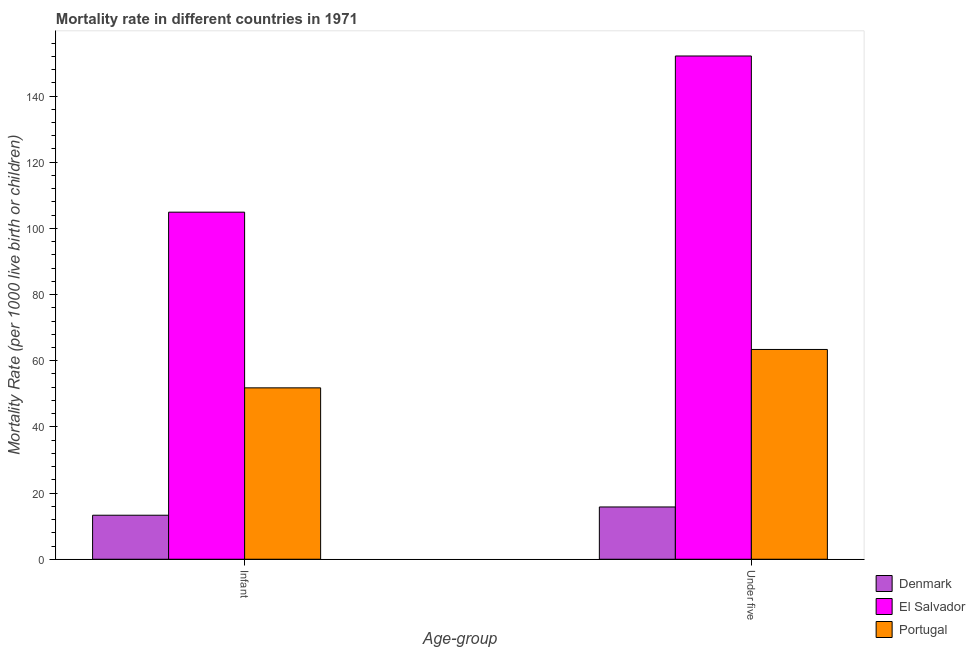How many groups of bars are there?
Your response must be concise. 2. Are the number of bars per tick equal to the number of legend labels?
Provide a short and direct response. Yes. Are the number of bars on each tick of the X-axis equal?
Offer a terse response. Yes. How many bars are there on the 2nd tick from the left?
Your answer should be very brief. 3. What is the label of the 2nd group of bars from the left?
Keep it short and to the point. Under five. What is the infant mortality rate in Portugal?
Ensure brevity in your answer.  51.8. Across all countries, what is the maximum infant mortality rate?
Provide a short and direct response. 104.9. In which country was the under-5 mortality rate maximum?
Offer a very short reply. El Salvador. What is the total infant mortality rate in the graph?
Provide a short and direct response. 170. What is the difference between the under-5 mortality rate in El Salvador and that in Portugal?
Your answer should be compact. 88.7. What is the difference between the infant mortality rate in Denmark and the under-5 mortality rate in Portugal?
Ensure brevity in your answer.  -50.1. What is the average infant mortality rate per country?
Your response must be concise. 56.67. What is the difference between the under-5 mortality rate and infant mortality rate in Portugal?
Make the answer very short. 11.6. What is the ratio of the under-5 mortality rate in Denmark to that in Portugal?
Give a very brief answer. 0.25. In how many countries, is the infant mortality rate greater than the average infant mortality rate taken over all countries?
Provide a succinct answer. 1. What does the 2nd bar from the left in Under five represents?
Provide a succinct answer. El Salvador. How many bars are there?
Your response must be concise. 6. Are all the bars in the graph horizontal?
Ensure brevity in your answer.  No. How many countries are there in the graph?
Make the answer very short. 3. What is the difference between two consecutive major ticks on the Y-axis?
Your answer should be compact. 20. Are the values on the major ticks of Y-axis written in scientific E-notation?
Offer a terse response. No. Does the graph contain any zero values?
Provide a short and direct response. No. Does the graph contain grids?
Keep it short and to the point. No. Where does the legend appear in the graph?
Provide a short and direct response. Bottom right. How are the legend labels stacked?
Your answer should be compact. Vertical. What is the title of the graph?
Your answer should be compact. Mortality rate in different countries in 1971. Does "Croatia" appear as one of the legend labels in the graph?
Provide a short and direct response. No. What is the label or title of the X-axis?
Your response must be concise. Age-group. What is the label or title of the Y-axis?
Make the answer very short. Mortality Rate (per 1000 live birth or children). What is the Mortality Rate (per 1000 live birth or children) in Denmark in Infant?
Your answer should be very brief. 13.3. What is the Mortality Rate (per 1000 live birth or children) in El Salvador in Infant?
Provide a short and direct response. 104.9. What is the Mortality Rate (per 1000 live birth or children) of Portugal in Infant?
Make the answer very short. 51.8. What is the Mortality Rate (per 1000 live birth or children) in Denmark in Under five?
Offer a very short reply. 15.8. What is the Mortality Rate (per 1000 live birth or children) in El Salvador in Under five?
Offer a terse response. 152.1. What is the Mortality Rate (per 1000 live birth or children) of Portugal in Under five?
Offer a very short reply. 63.4. Across all Age-group, what is the maximum Mortality Rate (per 1000 live birth or children) of Denmark?
Provide a short and direct response. 15.8. Across all Age-group, what is the maximum Mortality Rate (per 1000 live birth or children) of El Salvador?
Ensure brevity in your answer.  152.1. Across all Age-group, what is the maximum Mortality Rate (per 1000 live birth or children) of Portugal?
Your answer should be very brief. 63.4. Across all Age-group, what is the minimum Mortality Rate (per 1000 live birth or children) of El Salvador?
Your answer should be compact. 104.9. Across all Age-group, what is the minimum Mortality Rate (per 1000 live birth or children) of Portugal?
Your answer should be compact. 51.8. What is the total Mortality Rate (per 1000 live birth or children) in Denmark in the graph?
Ensure brevity in your answer.  29.1. What is the total Mortality Rate (per 1000 live birth or children) in El Salvador in the graph?
Provide a succinct answer. 257. What is the total Mortality Rate (per 1000 live birth or children) in Portugal in the graph?
Keep it short and to the point. 115.2. What is the difference between the Mortality Rate (per 1000 live birth or children) of Denmark in Infant and that in Under five?
Offer a terse response. -2.5. What is the difference between the Mortality Rate (per 1000 live birth or children) in El Salvador in Infant and that in Under five?
Give a very brief answer. -47.2. What is the difference between the Mortality Rate (per 1000 live birth or children) of Portugal in Infant and that in Under five?
Offer a very short reply. -11.6. What is the difference between the Mortality Rate (per 1000 live birth or children) of Denmark in Infant and the Mortality Rate (per 1000 live birth or children) of El Salvador in Under five?
Keep it short and to the point. -138.8. What is the difference between the Mortality Rate (per 1000 live birth or children) of Denmark in Infant and the Mortality Rate (per 1000 live birth or children) of Portugal in Under five?
Provide a succinct answer. -50.1. What is the difference between the Mortality Rate (per 1000 live birth or children) of El Salvador in Infant and the Mortality Rate (per 1000 live birth or children) of Portugal in Under five?
Give a very brief answer. 41.5. What is the average Mortality Rate (per 1000 live birth or children) in Denmark per Age-group?
Ensure brevity in your answer.  14.55. What is the average Mortality Rate (per 1000 live birth or children) in El Salvador per Age-group?
Give a very brief answer. 128.5. What is the average Mortality Rate (per 1000 live birth or children) in Portugal per Age-group?
Make the answer very short. 57.6. What is the difference between the Mortality Rate (per 1000 live birth or children) of Denmark and Mortality Rate (per 1000 live birth or children) of El Salvador in Infant?
Offer a very short reply. -91.6. What is the difference between the Mortality Rate (per 1000 live birth or children) in Denmark and Mortality Rate (per 1000 live birth or children) in Portugal in Infant?
Offer a terse response. -38.5. What is the difference between the Mortality Rate (per 1000 live birth or children) of El Salvador and Mortality Rate (per 1000 live birth or children) of Portugal in Infant?
Offer a very short reply. 53.1. What is the difference between the Mortality Rate (per 1000 live birth or children) in Denmark and Mortality Rate (per 1000 live birth or children) in El Salvador in Under five?
Ensure brevity in your answer.  -136.3. What is the difference between the Mortality Rate (per 1000 live birth or children) in Denmark and Mortality Rate (per 1000 live birth or children) in Portugal in Under five?
Your answer should be very brief. -47.6. What is the difference between the Mortality Rate (per 1000 live birth or children) in El Salvador and Mortality Rate (per 1000 live birth or children) in Portugal in Under five?
Your response must be concise. 88.7. What is the ratio of the Mortality Rate (per 1000 live birth or children) of Denmark in Infant to that in Under five?
Provide a succinct answer. 0.84. What is the ratio of the Mortality Rate (per 1000 live birth or children) in El Salvador in Infant to that in Under five?
Offer a terse response. 0.69. What is the ratio of the Mortality Rate (per 1000 live birth or children) of Portugal in Infant to that in Under five?
Your answer should be very brief. 0.82. What is the difference between the highest and the second highest Mortality Rate (per 1000 live birth or children) in Denmark?
Provide a succinct answer. 2.5. What is the difference between the highest and the second highest Mortality Rate (per 1000 live birth or children) in El Salvador?
Your answer should be very brief. 47.2. What is the difference between the highest and the second highest Mortality Rate (per 1000 live birth or children) in Portugal?
Offer a terse response. 11.6. What is the difference between the highest and the lowest Mortality Rate (per 1000 live birth or children) of Denmark?
Provide a succinct answer. 2.5. What is the difference between the highest and the lowest Mortality Rate (per 1000 live birth or children) in El Salvador?
Your answer should be compact. 47.2. 